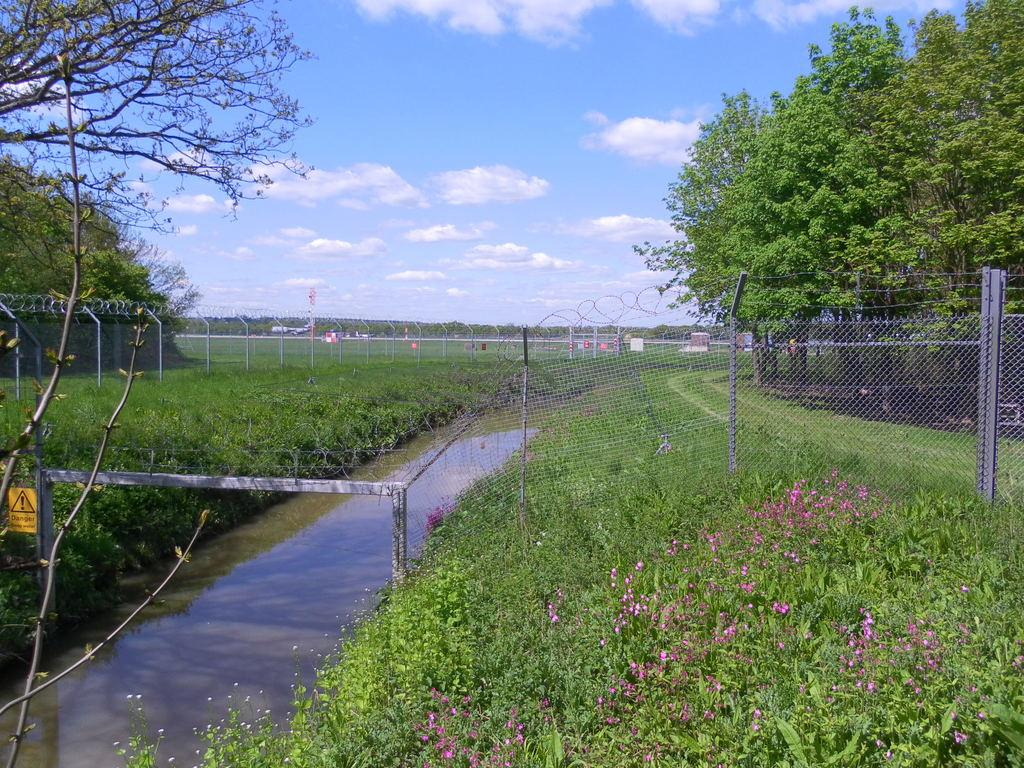What type of water feature is on the left side of the image? There is a canal on the left side of the image. What type of vegetation is at the bottom of the image? There is grass at the bottom of the image. What separates the grass from the canal in the image? There is a fence in the center of the image. What can be seen in the background of the image? There are trees and the sky visible in the background of the image. How many tomatoes are growing on the fence in the image? There are no tomatoes present in the image; the fence is not a garden or growing area. What type of blade is being used to cut the grass in the image? There is no blade or person cutting grass visible in the image. 